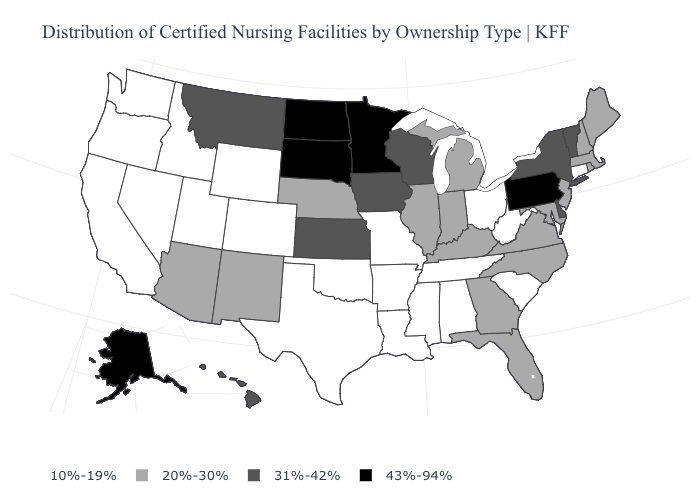What is the value of Virginia?
Be succinct. 20%-30%. Does the first symbol in the legend represent the smallest category?
Be succinct. Yes. Does New York have the lowest value in the USA?
Short answer required. No. Which states have the highest value in the USA?
Write a very short answer. Alaska, Minnesota, North Dakota, Pennsylvania, South Dakota. Name the states that have a value in the range 20%-30%?
Be succinct. Arizona, Florida, Georgia, Illinois, Indiana, Kentucky, Maine, Maryland, Massachusetts, Michigan, Nebraska, New Hampshire, New Jersey, New Mexico, North Carolina, Rhode Island, Virginia. What is the value of Iowa?
Be succinct. 31%-42%. What is the lowest value in states that border Montana?
Concise answer only. 10%-19%. Does the first symbol in the legend represent the smallest category?
Quick response, please. Yes. What is the highest value in the USA?
Write a very short answer. 43%-94%. Name the states that have a value in the range 31%-42%?
Give a very brief answer. Delaware, Hawaii, Iowa, Kansas, Montana, New York, Vermont, Wisconsin. Name the states that have a value in the range 20%-30%?
Quick response, please. Arizona, Florida, Georgia, Illinois, Indiana, Kentucky, Maine, Maryland, Massachusetts, Michigan, Nebraska, New Hampshire, New Jersey, New Mexico, North Carolina, Rhode Island, Virginia. Does California have the lowest value in the USA?
Short answer required. Yes. Which states have the lowest value in the MidWest?
Answer briefly. Missouri, Ohio. Name the states that have a value in the range 20%-30%?
Write a very short answer. Arizona, Florida, Georgia, Illinois, Indiana, Kentucky, Maine, Maryland, Massachusetts, Michigan, Nebraska, New Hampshire, New Jersey, New Mexico, North Carolina, Rhode Island, Virginia. What is the lowest value in the USA?
Quick response, please. 10%-19%. 